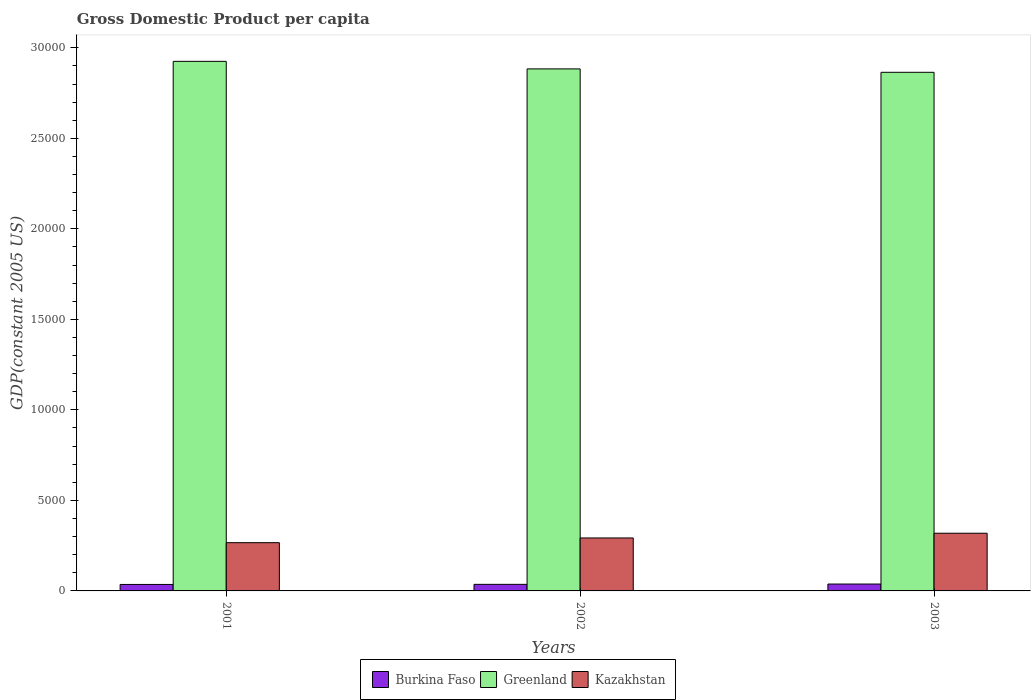How many different coloured bars are there?
Offer a very short reply. 3. Are the number of bars on each tick of the X-axis equal?
Offer a very short reply. Yes. How many bars are there on the 1st tick from the left?
Your answer should be compact. 3. How many bars are there on the 1st tick from the right?
Your answer should be compact. 3. In how many cases, is the number of bars for a given year not equal to the number of legend labels?
Offer a very short reply. 0. What is the GDP per capita in Kazakhstan in 2003?
Ensure brevity in your answer.  3186.76. Across all years, what is the maximum GDP per capita in Burkina Faso?
Your answer should be compact. 380.33. Across all years, what is the minimum GDP per capita in Greenland?
Offer a very short reply. 2.86e+04. In which year was the GDP per capita in Burkina Faso maximum?
Ensure brevity in your answer.  2003. In which year was the GDP per capita in Burkina Faso minimum?
Make the answer very short. 2001. What is the total GDP per capita in Burkina Faso in the graph?
Give a very brief answer. 1101.6. What is the difference between the GDP per capita in Burkina Faso in 2002 and that in 2003?
Ensure brevity in your answer.  -17.18. What is the difference between the GDP per capita in Greenland in 2003 and the GDP per capita in Kazakhstan in 2002?
Provide a short and direct response. 2.57e+04. What is the average GDP per capita in Burkina Faso per year?
Offer a terse response. 367.2. In the year 2001, what is the difference between the GDP per capita in Burkina Faso and GDP per capita in Greenland?
Provide a short and direct response. -2.89e+04. In how many years, is the GDP per capita in Burkina Faso greater than 20000 US$?
Keep it short and to the point. 0. What is the ratio of the GDP per capita in Greenland in 2002 to that in 2003?
Provide a succinct answer. 1.01. Is the GDP per capita in Greenland in 2001 less than that in 2002?
Offer a very short reply. No. Is the difference between the GDP per capita in Burkina Faso in 2002 and 2003 greater than the difference between the GDP per capita in Greenland in 2002 and 2003?
Your response must be concise. No. What is the difference between the highest and the second highest GDP per capita in Kazakhstan?
Keep it short and to the point. 261.33. What is the difference between the highest and the lowest GDP per capita in Burkina Faso?
Offer a terse response. 22.21. What does the 3rd bar from the left in 2003 represents?
Provide a succinct answer. Kazakhstan. What does the 2nd bar from the right in 2001 represents?
Provide a succinct answer. Greenland. Is it the case that in every year, the sum of the GDP per capita in Burkina Faso and GDP per capita in Kazakhstan is greater than the GDP per capita in Greenland?
Make the answer very short. No. How many bars are there?
Your response must be concise. 9. Are all the bars in the graph horizontal?
Offer a very short reply. No. How many years are there in the graph?
Give a very brief answer. 3. What is the difference between two consecutive major ticks on the Y-axis?
Offer a terse response. 5000. Are the values on the major ticks of Y-axis written in scientific E-notation?
Provide a succinct answer. No. Does the graph contain any zero values?
Your answer should be very brief. No. Where does the legend appear in the graph?
Ensure brevity in your answer.  Bottom center. How are the legend labels stacked?
Make the answer very short. Horizontal. What is the title of the graph?
Keep it short and to the point. Gross Domestic Product per capita. What is the label or title of the X-axis?
Offer a very short reply. Years. What is the label or title of the Y-axis?
Ensure brevity in your answer.  GDP(constant 2005 US). What is the GDP(constant 2005 US) in Burkina Faso in 2001?
Give a very brief answer. 358.12. What is the GDP(constant 2005 US) in Greenland in 2001?
Your answer should be compact. 2.93e+04. What is the GDP(constant 2005 US) in Kazakhstan in 2001?
Offer a terse response. 2664.44. What is the GDP(constant 2005 US) of Burkina Faso in 2002?
Offer a very short reply. 363.15. What is the GDP(constant 2005 US) of Greenland in 2002?
Ensure brevity in your answer.  2.88e+04. What is the GDP(constant 2005 US) of Kazakhstan in 2002?
Offer a very short reply. 2925.44. What is the GDP(constant 2005 US) in Burkina Faso in 2003?
Provide a succinct answer. 380.33. What is the GDP(constant 2005 US) of Greenland in 2003?
Offer a terse response. 2.86e+04. What is the GDP(constant 2005 US) in Kazakhstan in 2003?
Provide a succinct answer. 3186.76. Across all years, what is the maximum GDP(constant 2005 US) of Burkina Faso?
Your response must be concise. 380.33. Across all years, what is the maximum GDP(constant 2005 US) of Greenland?
Your answer should be compact. 2.93e+04. Across all years, what is the maximum GDP(constant 2005 US) of Kazakhstan?
Offer a very short reply. 3186.76. Across all years, what is the minimum GDP(constant 2005 US) of Burkina Faso?
Your response must be concise. 358.12. Across all years, what is the minimum GDP(constant 2005 US) in Greenland?
Make the answer very short. 2.86e+04. Across all years, what is the minimum GDP(constant 2005 US) in Kazakhstan?
Your answer should be compact. 2664.44. What is the total GDP(constant 2005 US) of Burkina Faso in the graph?
Give a very brief answer. 1101.6. What is the total GDP(constant 2005 US) in Greenland in the graph?
Your response must be concise. 8.67e+04. What is the total GDP(constant 2005 US) of Kazakhstan in the graph?
Ensure brevity in your answer.  8776.64. What is the difference between the GDP(constant 2005 US) of Burkina Faso in 2001 and that in 2002?
Provide a short and direct response. -5.03. What is the difference between the GDP(constant 2005 US) in Greenland in 2001 and that in 2002?
Ensure brevity in your answer.  416.62. What is the difference between the GDP(constant 2005 US) of Kazakhstan in 2001 and that in 2002?
Your response must be concise. -260.99. What is the difference between the GDP(constant 2005 US) in Burkina Faso in 2001 and that in 2003?
Keep it short and to the point. -22.21. What is the difference between the GDP(constant 2005 US) in Greenland in 2001 and that in 2003?
Your answer should be compact. 605.02. What is the difference between the GDP(constant 2005 US) in Kazakhstan in 2001 and that in 2003?
Provide a short and direct response. -522.32. What is the difference between the GDP(constant 2005 US) of Burkina Faso in 2002 and that in 2003?
Provide a succinct answer. -17.18. What is the difference between the GDP(constant 2005 US) in Greenland in 2002 and that in 2003?
Provide a succinct answer. 188.41. What is the difference between the GDP(constant 2005 US) in Kazakhstan in 2002 and that in 2003?
Keep it short and to the point. -261.33. What is the difference between the GDP(constant 2005 US) in Burkina Faso in 2001 and the GDP(constant 2005 US) in Greenland in 2002?
Make the answer very short. -2.85e+04. What is the difference between the GDP(constant 2005 US) in Burkina Faso in 2001 and the GDP(constant 2005 US) in Kazakhstan in 2002?
Provide a short and direct response. -2567.32. What is the difference between the GDP(constant 2005 US) in Greenland in 2001 and the GDP(constant 2005 US) in Kazakhstan in 2002?
Offer a terse response. 2.63e+04. What is the difference between the GDP(constant 2005 US) of Burkina Faso in 2001 and the GDP(constant 2005 US) of Greenland in 2003?
Make the answer very short. -2.83e+04. What is the difference between the GDP(constant 2005 US) of Burkina Faso in 2001 and the GDP(constant 2005 US) of Kazakhstan in 2003?
Keep it short and to the point. -2828.64. What is the difference between the GDP(constant 2005 US) in Greenland in 2001 and the GDP(constant 2005 US) in Kazakhstan in 2003?
Keep it short and to the point. 2.61e+04. What is the difference between the GDP(constant 2005 US) of Burkina Faso in 2002 and the GDP(constant 2005 US) of Greenland in 2003?
Ensure brevity in your answer.  -2.83e+04. What is the difference between the GDP(constant 2005 US) in Burkina Faso in 2002 and the GDP(constant 2005 US) in Kazakhstan in 2003?
Offer a terse response. -2823.61. What is the difference between the GDP(constant 2005 US) of Greenland in 2002 and the GDP(constant 2005 US) of Kazakhstan in 2003?
Ensure brevity in your answer.  2.56e+04. What is the average GDP(constant 2005 US) in Burkina Faso per year?
Provide a short and direct response. 367.2. What is the average GDP(constant 2005 US) of Greenland per year?
Give a very brief answer. 2.89e+04. What is the average GDP(constant 2005 US) of Kazakhstan per year?
Offer a very short reply. 2925.55. In the year 2001, what is the difference between the GDP(constant 2005 US) of Burkina Faso and GDP(constant 2005 US) of Greenland?
Your response must be concise. -2.89e+04. In the year 2001, what is the difference between the GDP(constant 2005 US) of Burkina Faso and GDP(constant 2005 US) of Kazakhstan?
Your answer should be compact. -2306.32. In the year 2001, what is the difference between the GDP(constant 2005 US) of Greenland and GDP(constant 2005 US) of Kazakhstan?
Make the answer very short. 2.66e+04. In the year 2002, what is the difference between the GDP(constant 2005 US) of Burkina Faso and GDP(constant 2005 US) of Greenland?
Make the answer very short. -2.85e+04. In the year 2002, what is the difference between the GDP(constant 2005 US) of Burkina Faso and GDP(constant 2005 US) of Kazakhstan?
Offer a very short reply. -2562.28. In the year 2002, what is the difference between the GDP(constant 2005 US) of Greenland and GDP(constant 2005 US) of Kazakhstan?
Your response must be concise. 2.59e+04. In the year 2003, what is the difference between the GDP(constant 2005 US) of Burkina Faso and GDP(constant 2005 US) of Greenland?
Offer a very short reply. -2.83e+04. In the year 2003, what is the difference between the GDP(constant 2005 US) in Burkina Faso and GDP(constant 2005 US) in Kazakhstan?
Ensure brevity in your answer.  -2806.44. In the year 2003, what is the difference between the GDP(constant 2005 US) of Greenland and GDP(constant 2005 US) of Kazakhstan?
Your answer should be compact. 2.55e+04. What is the ratio of the GDP(constant 2005 US) of Burkina Faso in 2001 to that in 2002?
Your response must be concise. 0.99. What is the ratio of the GDP(constant 2005 US) of Greenland in 2001 to that in 2002?
Offer a very short reply. 1.01. What is the ratio of the GDP(constant 2005 US) in Kazakhstan in 2001 to that in 2002?
Make the answer very short. 0.91. What is the ratio of the GDP(constant 2005 US) of Burkina Faso in 2001 to that in 2003?
Your response must be concise. 0.94. What is the ratio of the GDP(constant 2005 US) of Greenland in 2001 to that in 2003?
Ensure brevity in your answer.  1.02. What is the ratio of the GDP(constant 2005 US) of Kazakhstan in 2001 to that in 2003?
Your answer should be very brief. 0.84. What is the ratio of the GDP(constant 2005 US) of Burkina Faso in 2002 to that in 2003?
Make the answer very short. 0.95. What is the ratio of the GDP(constant 2005 US) in Greenland in 2002 to that in 2003?
Give a very brief answer. 1.01. What is the ratio of the GDP(constant 2005 US) of Kazakhstan in 2002 to that in 2003?
Your answer should be very brief. 0.92. What is the difference between the highest and the second highest GDP(constant 2005 US) in Burkina Faso?
Ensure brevity in your answer.  17.18. What is the difference between the highest and the second highest GDP(constant 2005 US) of Greenland?
Offer a terse response. 416.62. What is the difference between the highest and the second highest GDP(constant 2005 US) in Kazakhstan?
Provide a short and direct response. 261.33. What is the difference between the highest and the lowest GDP(constant 2005 US) of Burkina Faso?
Your response must be concise. 22.21. What is the difference between the highest and the lowest GDP(constant 2005 US) of Greenland?
Ensure brevity in your answer.  605.02. What is the difference between the highest and the lowest GDP(constant 2005 US) of Kazakhstan?
Provide a short and direct response. 522.32. 